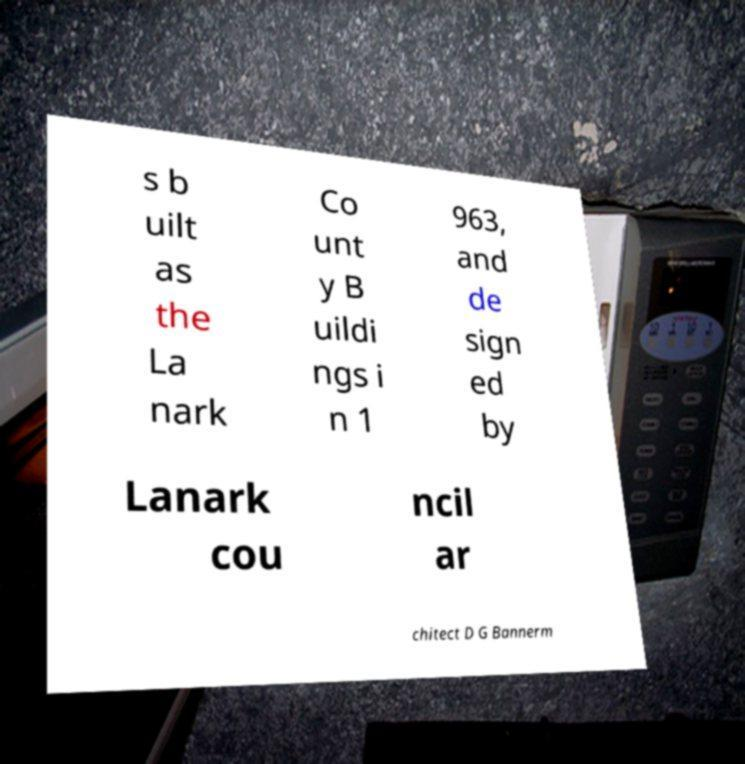Could you assist in decoding the text presented in this image and type it out clearly? s b uilt as the La nark Co unt y B uildi ngs i n 1 963, and de sign ed by Lanark cou ncil ar chitect D G Bannerm 